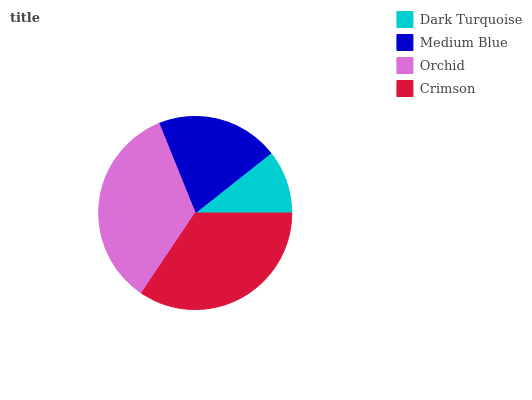Is Dark Turquoise the minimum?
Answer yes or no. Yes. Is Orchid the maximum?
Answer yes or no. Yes. Is Medium Blue the minimum?
Answer yes or no. No. Is Medium Blue the maximum?
Answer yes or no. No. Is Medium Blue greater than Dark Turquoise?
Answer yes or no. Yes. Is Dark Turquoise less than Medium Blue?
Answer yes or no. Yes. Is Dark Turquoise greater than Medium Blue?
Answer yes or no. No. Is Medium Blue less than Dark Turquoise?
Answer yes or no. No. Is Crimson the high median?
Answer yes or no. Yes. Is Medium Blue the low median?
Answer yes or no. Yes. Is Dark Turquoise the high median?
Answer yes or no. No. Is Orchid the low median?
Answer yes or no. No. 